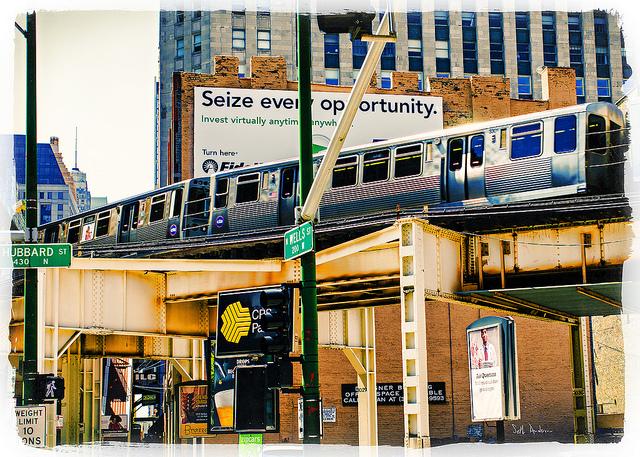According to the billboard, what should be seized?
Write a very short answer. Every opportunity. Is there construction going on?
Give a very brief answer. Yes. Is it daytime?
Write a very short answer. Yes. 